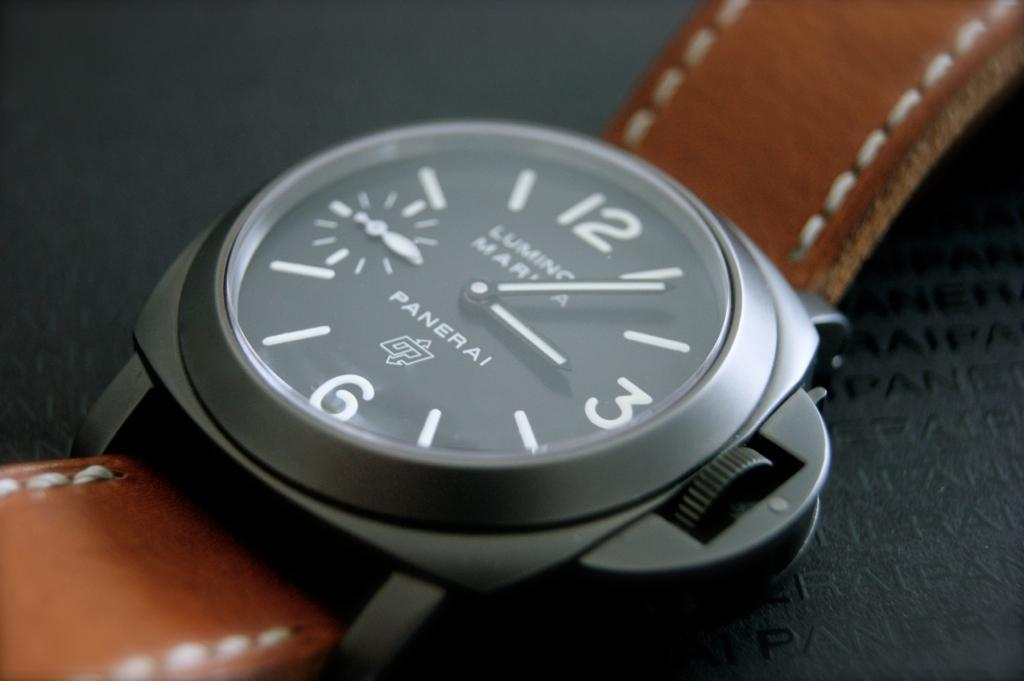<image>
Describe the image concisely. A wristwatch has the word Panerai on its face. 